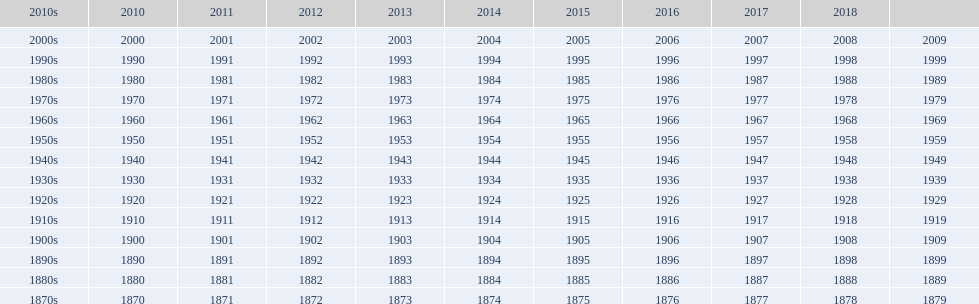True/false: all years proceed in sequential arrangement? True. 